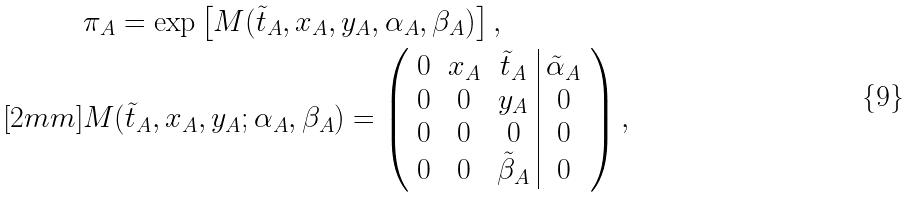<formula> <loc_0><loc_0><loc_500><loc_500>& \pi _ { A } = \exp \left [ M ( \tilde { t } _ { A } , x _ { A } , y _ { A } , \alpha _ { A } , \beta _ { A } ) \right ] , \\ [ 2 m m ] & M ( \tilde { t } _ { A } , x _ { A } , y _ { A } ; \alpha _ { A } , \beta _ { A } ) = \left ( \begin{array} { c c c | c } 0 & x _ { A } & \tilde { t } _ { A } & \tilde { \alpha } _ { A } \\ 0 & 0 & y _ { A } & 0 \\ 0 & 0 & 0 & 0 \\ 0 & 0 & \tilde { \beta } _ { A } & 0 \end{array} \right ) ,</formula> 